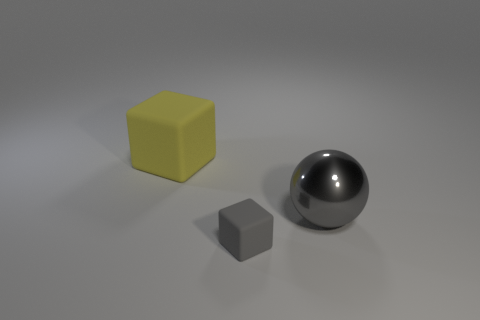Add 2 yellow rubber blocks. How many objects exist? 5 Subtract all blocks. How many objects are left? 1 Subtract all small cyan things. Subtract all big matte things. How many objects are left? 2 Add 3 small rubber objects. How many small rubber objects are left? 4 Add 1 big gray objects. How many big gray objects exist? 2 Subtract 0 red cylinders. How many objects are left? 3 